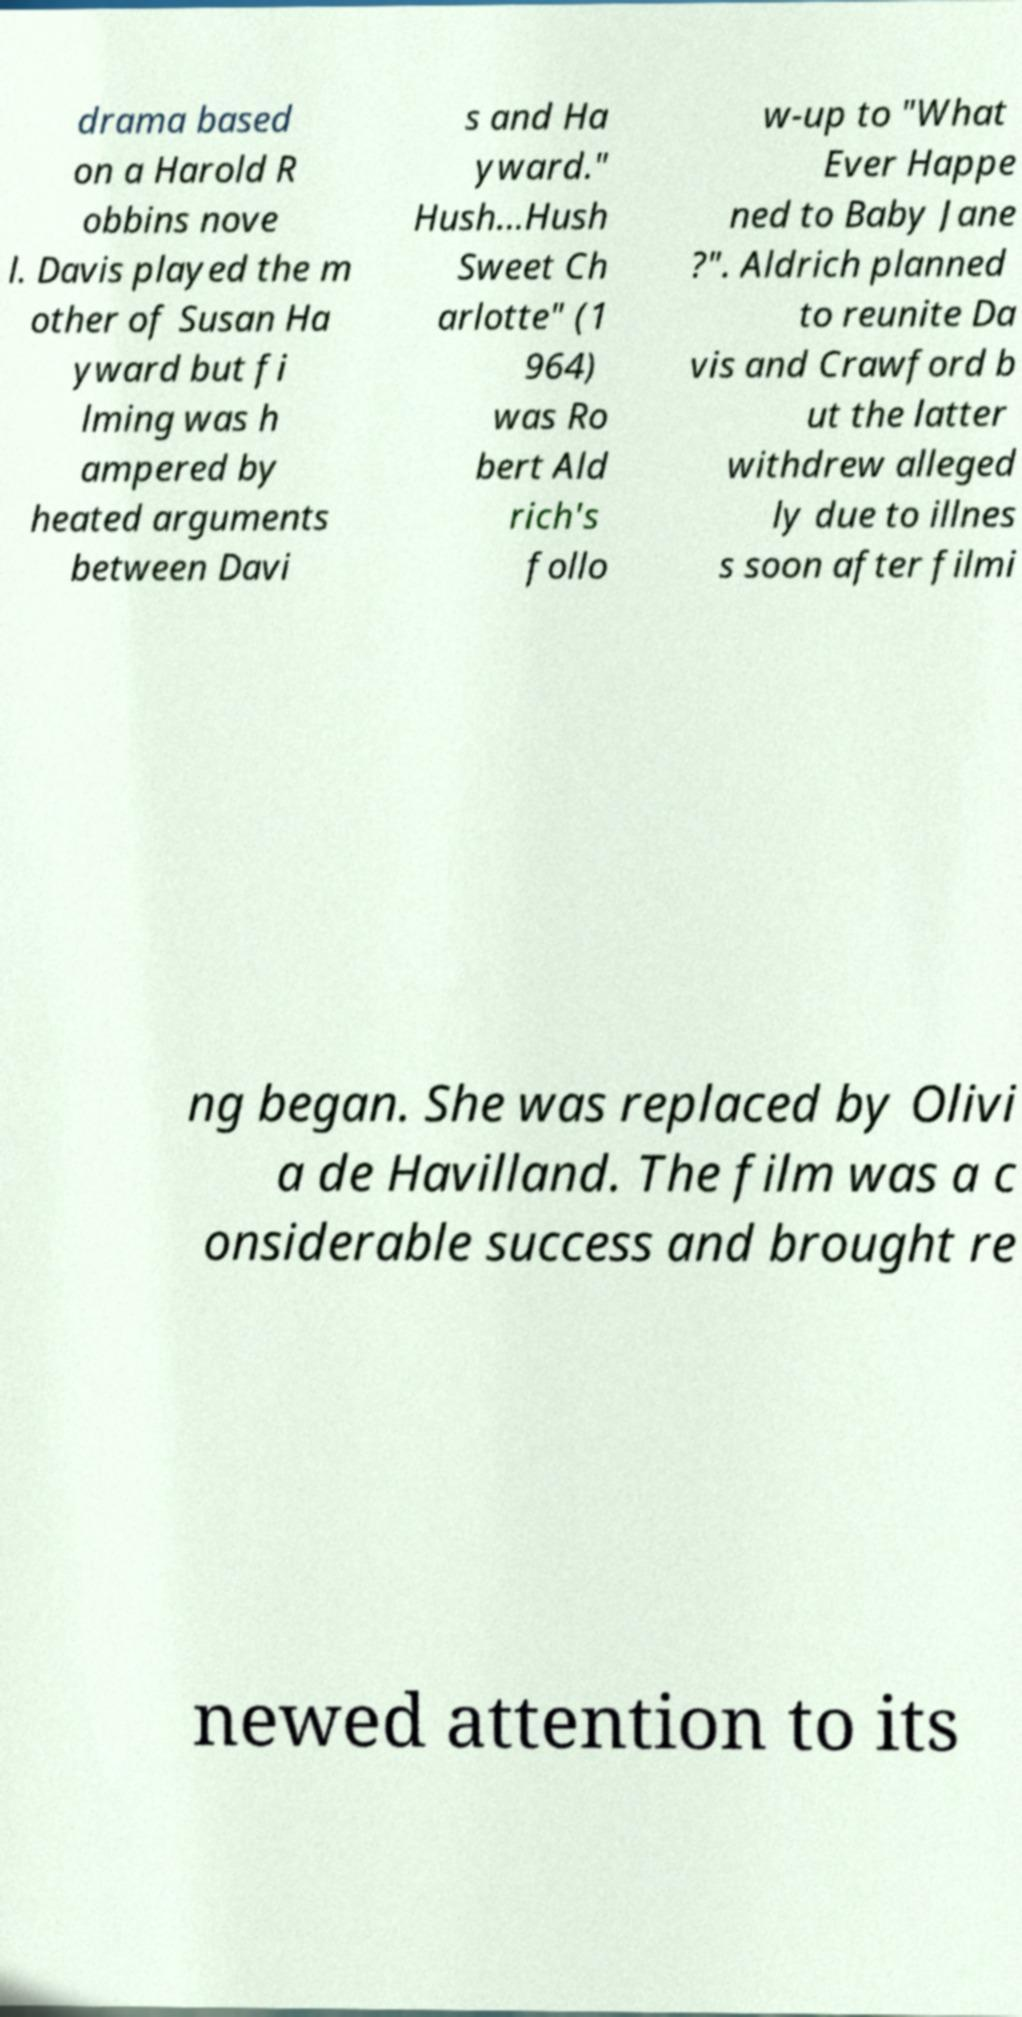Please identify and transcribe the text found in this image. drama based on a Harold R obbins nove l. Davis played the m other of Susan Ha yward but fi lming was h ampered by heated arguments between Davi s and Ha yward." Hush...Hush Sweet Ch arlotte" (1 964) was Ro bert Ald rich's follo w-up to "What Ever Happe ned to Baby Jane ?". Aldrich planned to reunite Da vis and Crawford b ut the latter withdrew alleged ly due to illnes s soon after filmi ng began. She was replaced by Olivi a de Havilland. The film was a c onsiderable success and brought re newed attention to its 